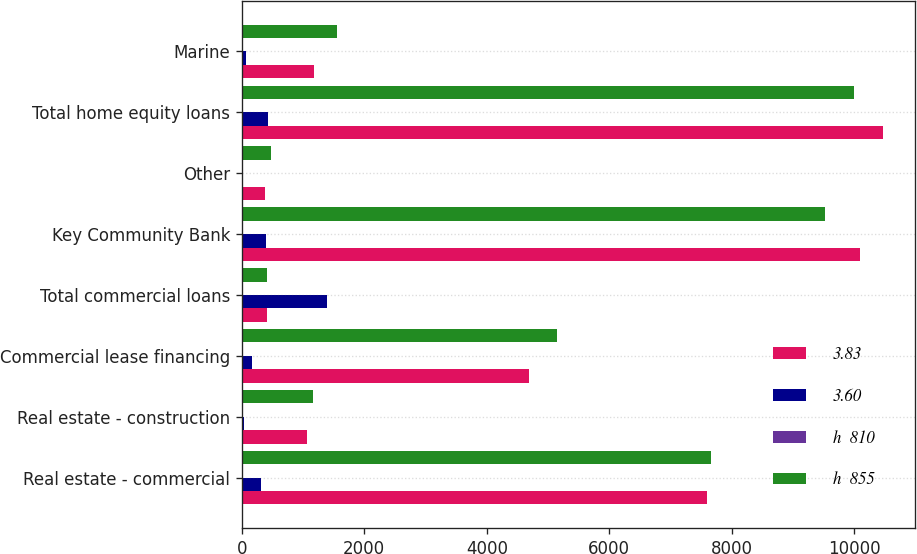Convert chart to OTSL. <chart><loc_0><loc_0><loc_500><loc_500><stacked_bar_chart><ecel><fcel>Real estate - commercial<fcel>Real estate - construction<fcel>Commercial lease financing<fcel>Total commercial loans<fcel>Key Community Bank<fcel>Other<fcel>Total home equity loans<fcel>Marine<nl><fcel>3.83<fcel>7591<fcel>1058<fcel>4683<fcel>411.5<fcel>10086<fcel>377<fcel>10463<fcel>1172<nl><fcel>3.60<fcel>312<fcel>45<fcel>172<fcel>1384<fcel>397<fcel>29<fcel>426<fcel>74<nl><fcel>h  810<fcel>4.11<fcel>4.25<fcel>3.67<fcel>3.73<fcel>3.93<fcel>7.7<fcel>4.07<fcel>6.26<nl><fcel>h  855<fcel>7656<fcel>1171<fcel>5142<fcel>411.5<fcel>9520<fcel>473<fcel>9993<fcel>1551<nl></chart> 